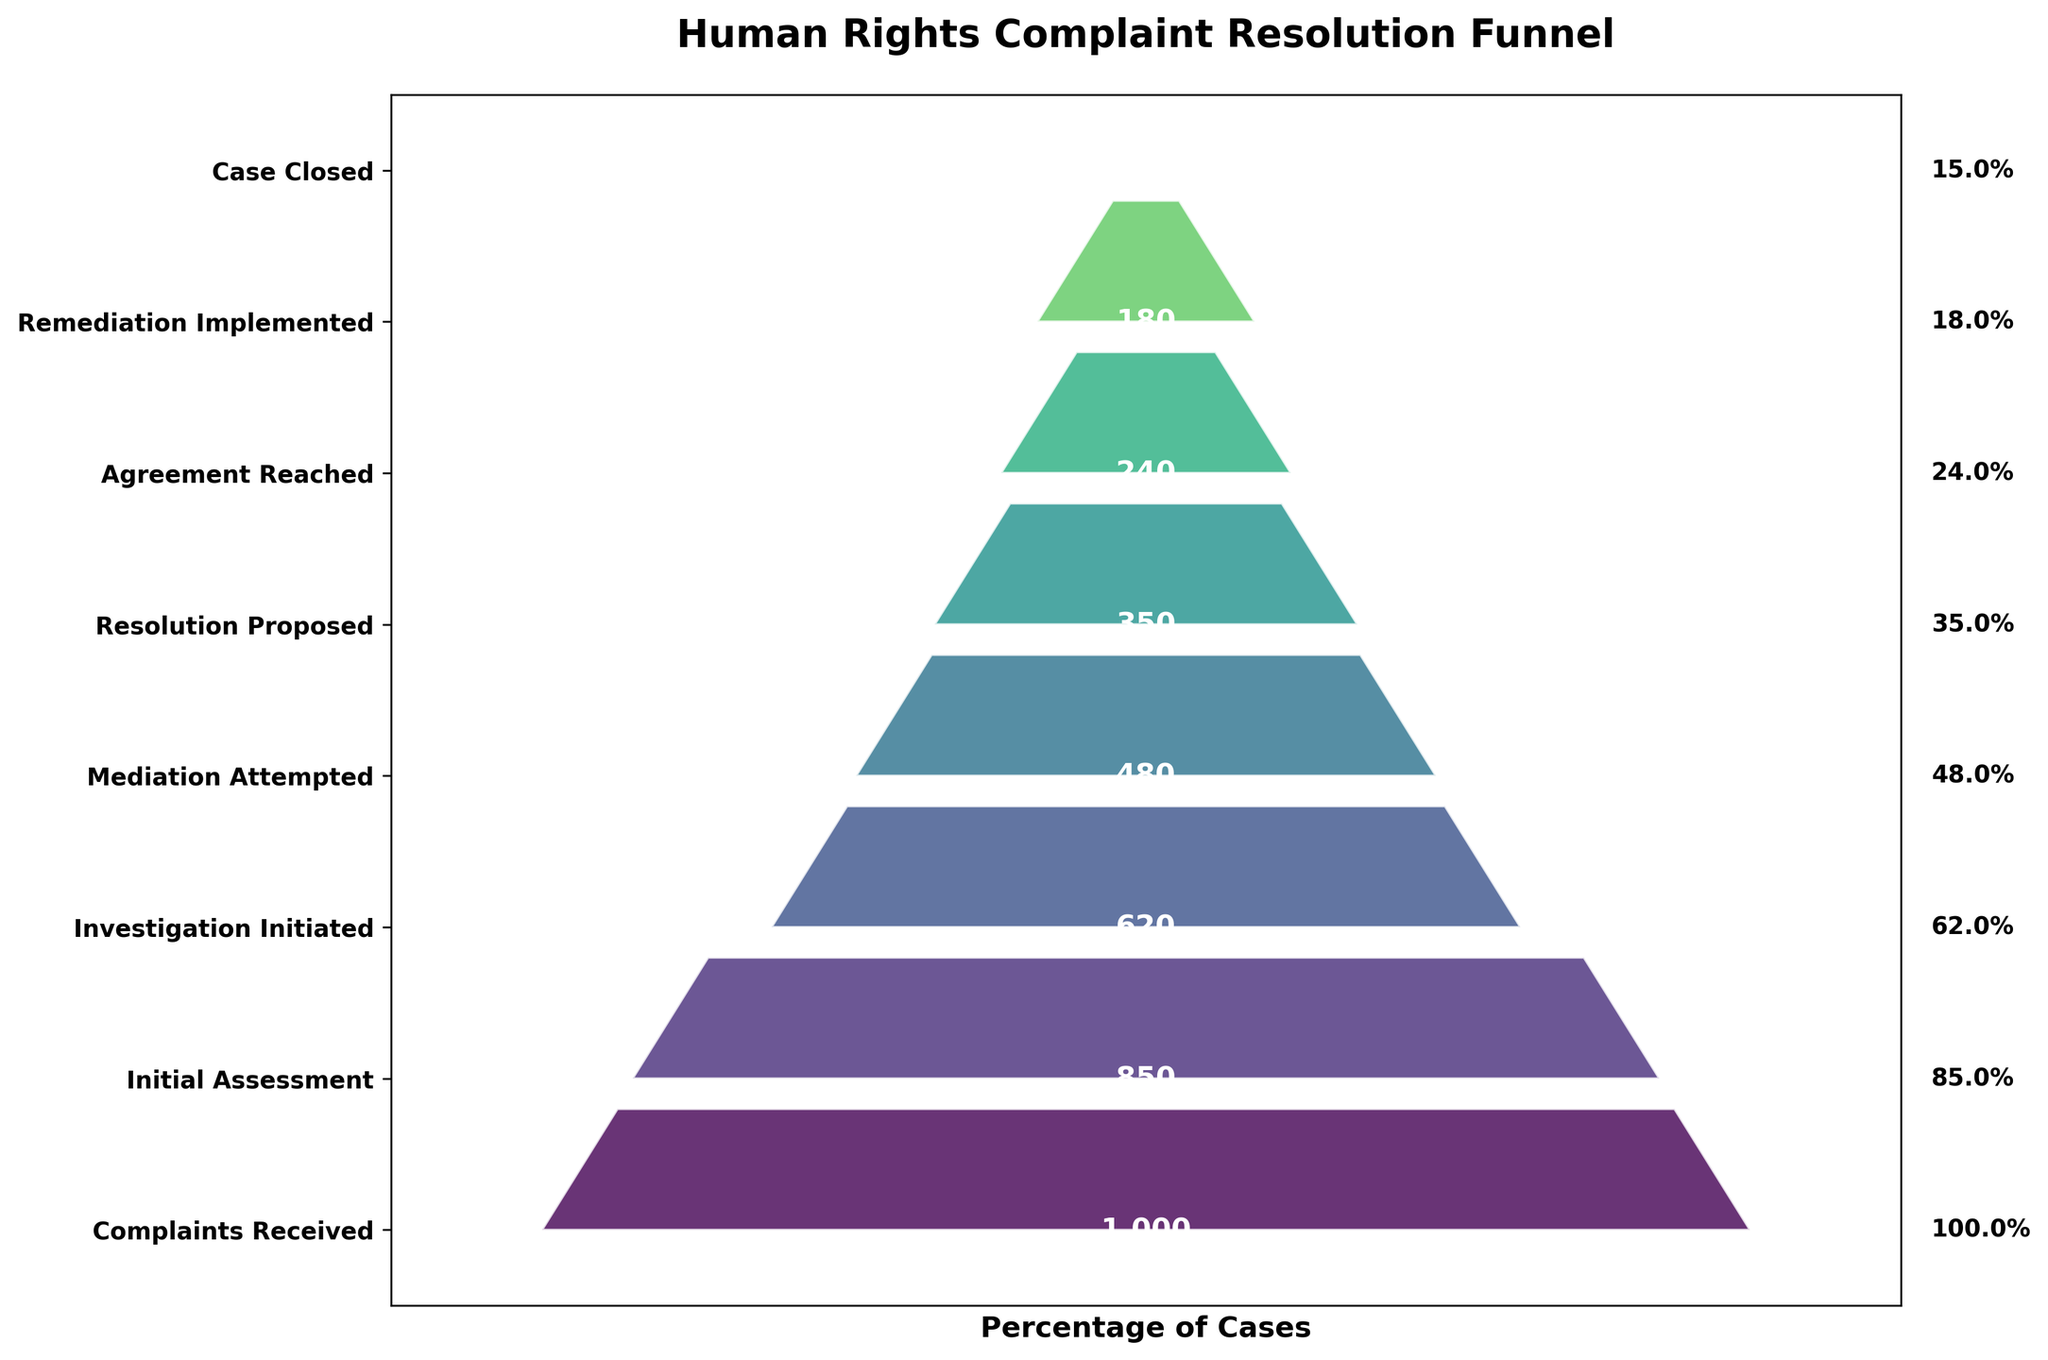Which step has the highest number of cases? The Complaints Received step has the highest number of cases. This is evident from its position at the top of the funnel and the associated case number.
Answer: Complaints Received What is the title of the funnel chart? The title of the funnel chart is displayed at the top and reads "Human Rights Complaint Resolution Funnel."
Answer: Human Rights Complaint Resolution Funnel How many cases were left after the Initial Assessment step? According to the figure, the number of cases after the Initial Assessment step is 850. This can be observed from the label next to the corresponding segment.
Answer: 850 How many cases are closed at the final step? The final step indicates the number of cases closed, which is shown as 150.
Answer: 150 What percentage of complaints reached the Investigation Initiated step? The percentage of complaints that reached the Investigation Initiated step is calculated as (620/1000) * 100 = 62%. This value is displayed on the right of the corresponding segment.
Answer: 62.0% How many cases were dropped between the Initial Assessment and the Investigation Initiated steps? The cases dropped are found by subtracting the cases in the Investigation Initiated step from those in the Initial Assessment step: 850 - 620 = 230.
Answer: 230 Which step had the largest number of cases dropped from the previous step? Comparing the drops, the largest number is between Complaints Received (1000) and Initial Assessment (850): 1000 - 850 = 150.
Answer: Initial Assessment What is the trend observed from Complaints Received to Case Closed? The funnel chart shows a decreasing trend in the number of cases from Complaints Received to Case Closed, indicating that fewer cases progress through each subsequent step.
Answer: Decreasing trend How many steps are there in the funnel chart? Count the distinct segments of the funnel chart to determine the total number: Complaints Received, Initial Assessment, Investigation Initiated, Mediation Attempted, Resolution Proposed, Agreement Reached, Remediation Implemented, and Case Closed. There are 8 steps.
Answer: 8 What can you infer about the success rate of Agreement Reached to Remediation Implemented? The number of cases at Agreement Reached is 240, whereas Remediation Implemented is 180. The success rate is (180/240) * 100 = 75%.
Answer: 75.0% 